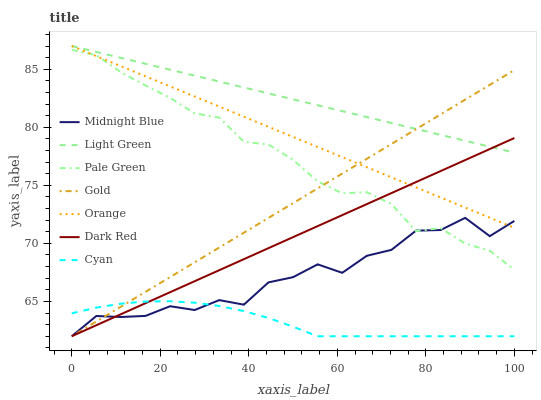Does Cyan have the minimum area under the curve?
Answer yes or no. Yes. Does Gold have the minimum area under the curve?
Answer yes or no. No. Does Gold have the maximum area under the curve?
Answer yes or no. No. Is Orange the smoothest?
Answer yes or no. Yes. Is Midnight Blue the roughest?
Answer yes or no. Yes. Is Gold the smoothest?
Answer yes or no. No. Is Gold the roughest?
Answer yes or no. No. Does Pale Green have the lowest value?
Answer yes or no. No. Does Gold have the highest value?
Answer yes or no. No. Is Cyan less than Pale Green?
Answer yes or no. Yes. Is Light Green greater than Midnight Blue?
Answer yes or no. Yes. Does Cyan intersect Pale Green?
Answer yes or no. No. 